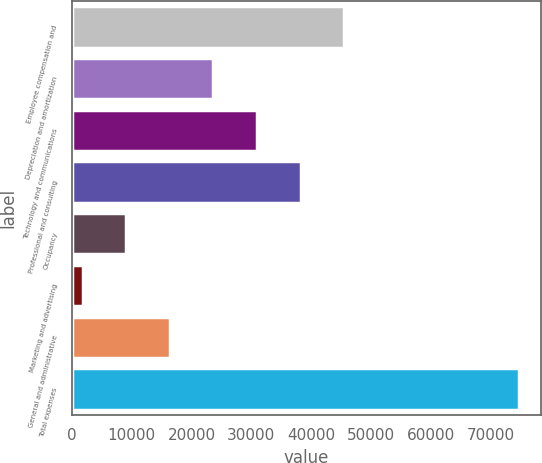Convert chart. <chart><loc_0><loc_0><loc_500><loc_500><bar_chart><fcel>Employee compensation and<fcel>Depreciation and amortization<fcel>Technology and communications<fcel>Professional and consulting<fcel>Occupancy<fcel>Marketing and advertising<fcel>General and administrative<fcel>Total expenses<nl><fcel>45534.8<fcel>23651.9<fcel>30946.2<fcel>38240.5<fcel>9063.3<fcel>1769<fcel>16357.6<fcel>74712<nl></chart> 